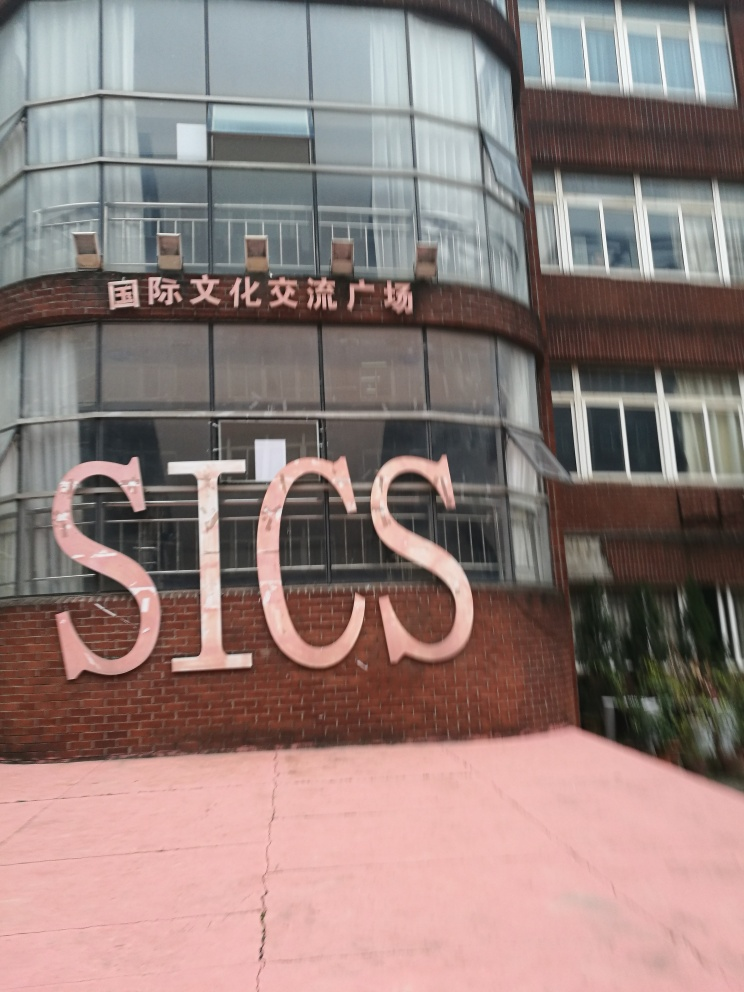Are there any quality issues with this image? Yes, the image appears to be blurry, which affects the clarity of the text and details on the building's facade. Additionally, the perspective is slightly skewed, possibly due to the angle of the shot, which can distort the perception of the building's structure. 